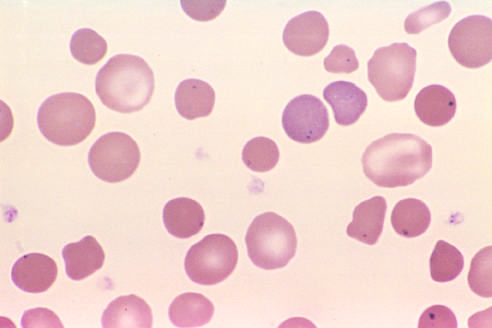re howell-jolly bodies present in the red cells of this asplenic patient?
Answer the question using a single word or phrase. Yes 